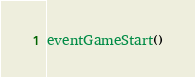Convert code to text. <code><loc_0><loc_0><loc_500><loc_500><_Lua_>eventGameStart()</code> 